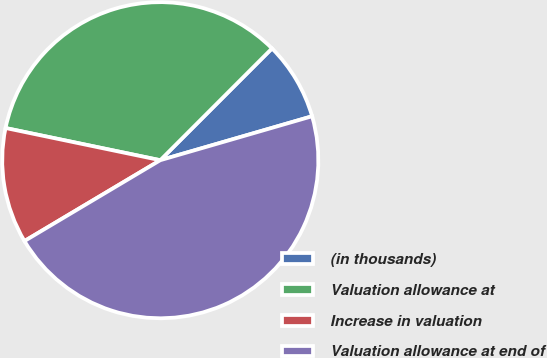<chart> <loc_0><loc_0><loc_500><loc_500><pie_chart><fcel>(in thousands)<fcel>Valuation allowance at<fcel>Increase in valuation<fcel>Valuation allowance at end of<nl><fcel>8.02%<fcel>34.23%<fcel>11.81%<fcel>45.94%<nl></chart> 